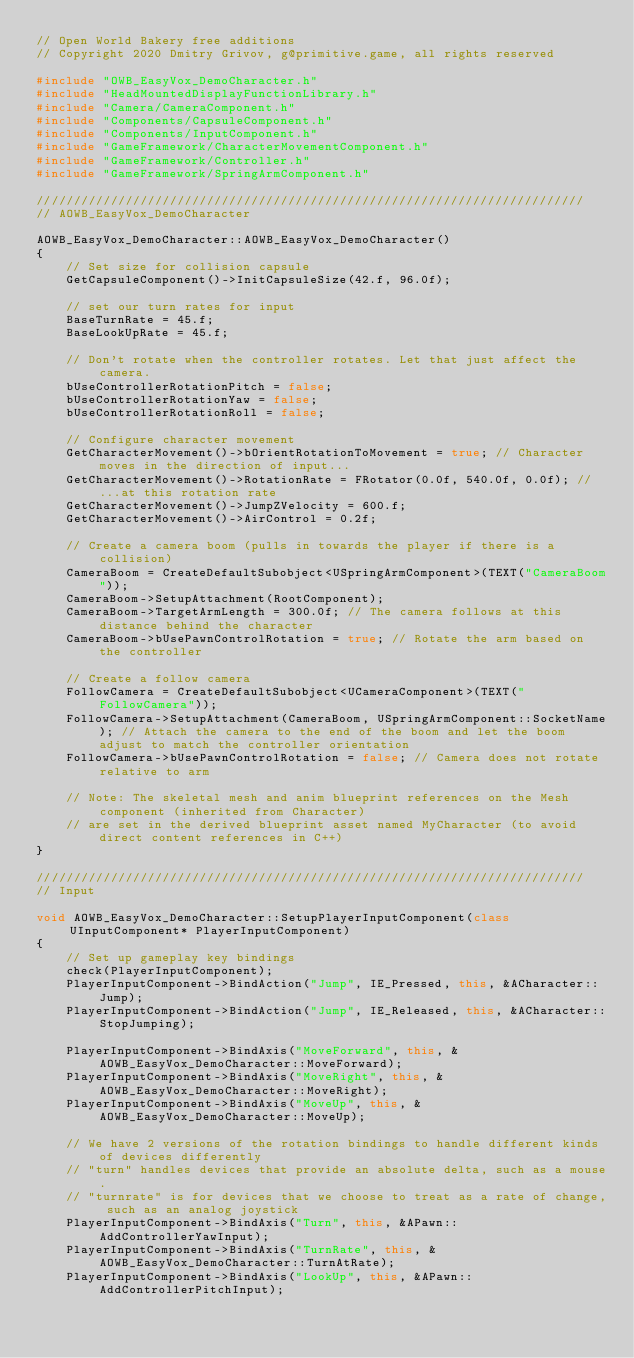Convert code to text. <code><loc_0><loc_0><loc_500><loc_500><_C++_>// Open World Bakery free additions
// Copyright 2020 Dmitry Grivov, g@primitive.game, all rights reserved

#include "OWB_EasyVox_DemoCharacter.h"
#include "HeadMountedDisplayFunctionLibrary.h"
#include "Camera/CameraComponent.h"
#include "Components/CapsuleComponent.h"
#include "Components/InputComponent.h"
#include "GameFramework/CharacterMovementComponent.h"
#include "GameFramework/Controller.h"
#include "GameFramework/SpringArmComponent.h"

//////////////////////////////////////////////////////////////////////////
// AOWB_EasyVox_DemoCharacter

AOWB_EasyVox_DemoCharacter::AOWB_EasyVox_DemoCharacter()
{
	// Set size for collision capsule
	GetCapsuleComponent()->InitCapsuleSize(42.f, 96.0f);

	// set our turn rates for input
	BaseTurnRate = 45.f;
	BaseLookUpRate = 45.f;

	// Don't rotate when the controller rotates. Let that just affect the camera.
	bUseControllerRotationPitch = false;
	bUseControllerRotationYaw = false;
	bUseControllerRotationRoll = false;

	// Configure character movement
	GetCharacterMovement()->bOrientRotationToMovement = true; // Character moves in the direction of input...	
	GetCharacterMovement()->RotationRate = FRotator(0.0f, 540.0f, 0.0f); // ...at this rotation rate
	GetCharacterMovement()->JumpZVelocity = 600.f;
	GetCharacterMovement()->AirControl = 0.2f;

	// Create a camera boom (pulls in towards the player if there is a collision)
	CameraBoom = CreateDefaultSubobject<USpringArmComponent>(TEXT("CameraBoom"));
	CameraBoom->SetupAttachment(RootComponent);
	CameraBoom->TargetArmLength = 300.0f; // The camera follows at this distance behind the character	
	CameraBoom->bUsePawnControlRotation = true; // Rotate the arm based on the controller

	// Create a follow camera
	FollowCamera = CreateDefaultSubobject<UCameraComponent>(TEXT("FollowCamera"));
	FollowCamera->SetupAttachment(CameraBoom, USpringArmComponent::SocketName); // Attach the camera to the end of the boom and let the boom adjust to match the controller orientation
	FollowCamera->bUsePawnControlRotation = false; // Camera does not rotate relative to arm

	// Note: The skeletal mesh and anim blueprint references on the Mesh component (inherited from Character) 
	// are set in the derived blueprint asset named MyCharacter (to avoid direct content references in C++)
}

//////////////////////////////////////////////////////////////////////////
// Input

void AOWB_EasyVox_DemoCharacter::SetupPlayerInputComponent(class UInputComponent* PlayerInputComponent)
{
	// Set up gameplay key bindings
	check(PlayerInputComponent);
	PlayerInputComponent->BindAction("Jump", IE_Pressed, this, &ACharacter::Jump);
	PlayerInputComponent->BindAction("Jump", IE_Released, this, &ACharacter::StopJumping);

	PlayerInputComponent->BindAxis("MoveForward", this, &AOWB_EasyVox_DemoCharacter::MoveForward);
	PlayerInputComponent->BindAxis("MoveRight", this, &AOWB_EasyVox_DemoCharacter::MoveRight);
	PlayerInputComponent->BindAxis("MoveUp", this, &AOWB_EasyVox_DemoCharacter::MoveUp);

	// We have 2 versions of the rotation bindings to handle different kinds of devices differently
	// "turn" handles devices that provide an absolute delta, such as a mouse.
	// "turnrate" is for devices that we choose to treat as a rate of change, such as an analog joystick
	PlayerInputComponent->BindAxis("Turn", this, &APawn::AddControllerYawInput);
	PlayerInputComponent->BindAxis("TurnRate", this, &AOWB_EasyVox_DemoCharacter::TurnAtRate);
	PlayerInputComponent->BindAxis("LookUp", this, &APawn::AddControllerPitchInput);</code> 